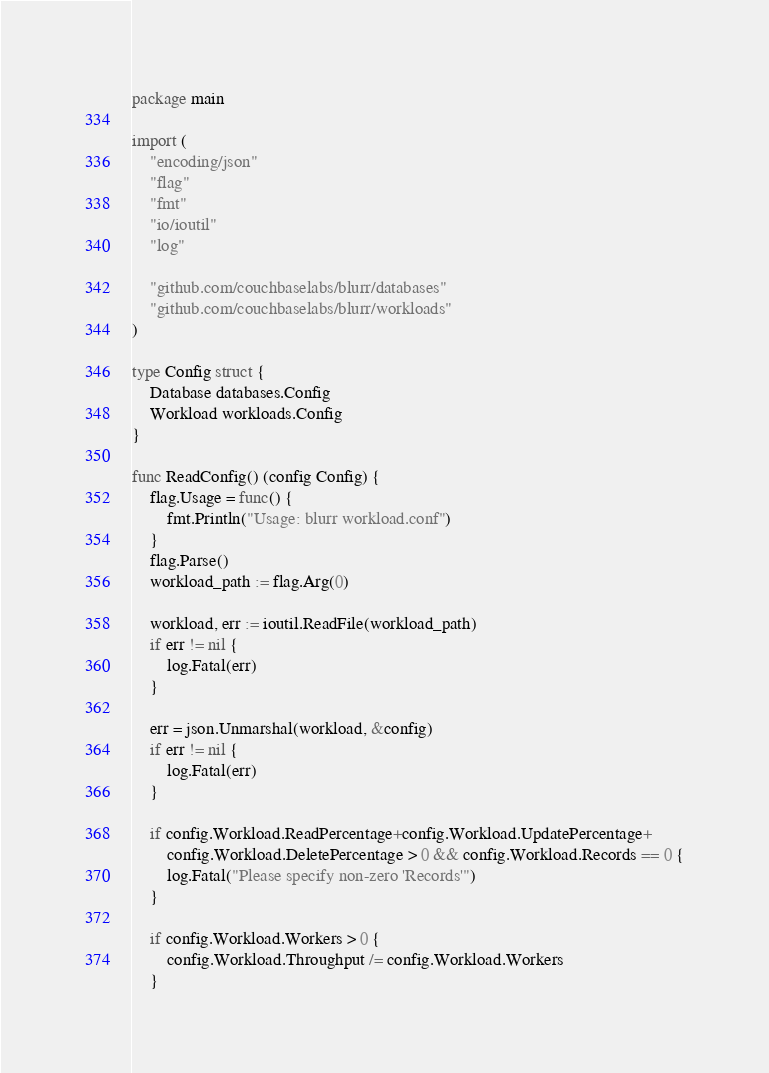<code> <loc_0><loc_0><loc_500><loc_500><_Go_>package main

import (
	"encoding/json"
	"flag"
	"fmt"
	"io/ioutil"
	"log"

	"github.com/couchbaselabs/blurr/databases"
	"github.com/couchbaselabs/blurr/workloads"
)

type Config struct {
	Database databases.Config
	Workload workloads.Config
}

func ReadConfig() (config Config) {
	flag.Usage = func() {
		fmt.Println("Usage: blurr workload.conf")
	}
	flag.Parse()
	workload_path := flag.Arg(0)

	workload, err := ioutil.ReadFile(workload_path)
	if err != nil {
		log.Fatal(err)
	}

	err = json.Unmarshal(workload, &config)
	if err != nil {
		log.Fatal(err)
	}

	if config.Workload.ReadPercentage+config.Workload.UpdatePercentage+
		config.Workload.DeletePercentage > 0 && config.Workload.Records == 0 {
		log.Fatal("Please specify non-zero 'Records'")
	}

	if config.Workload.Workers > 0 {
		config.Workload.Throughput /= config.Workload.Workers
	}</code> 